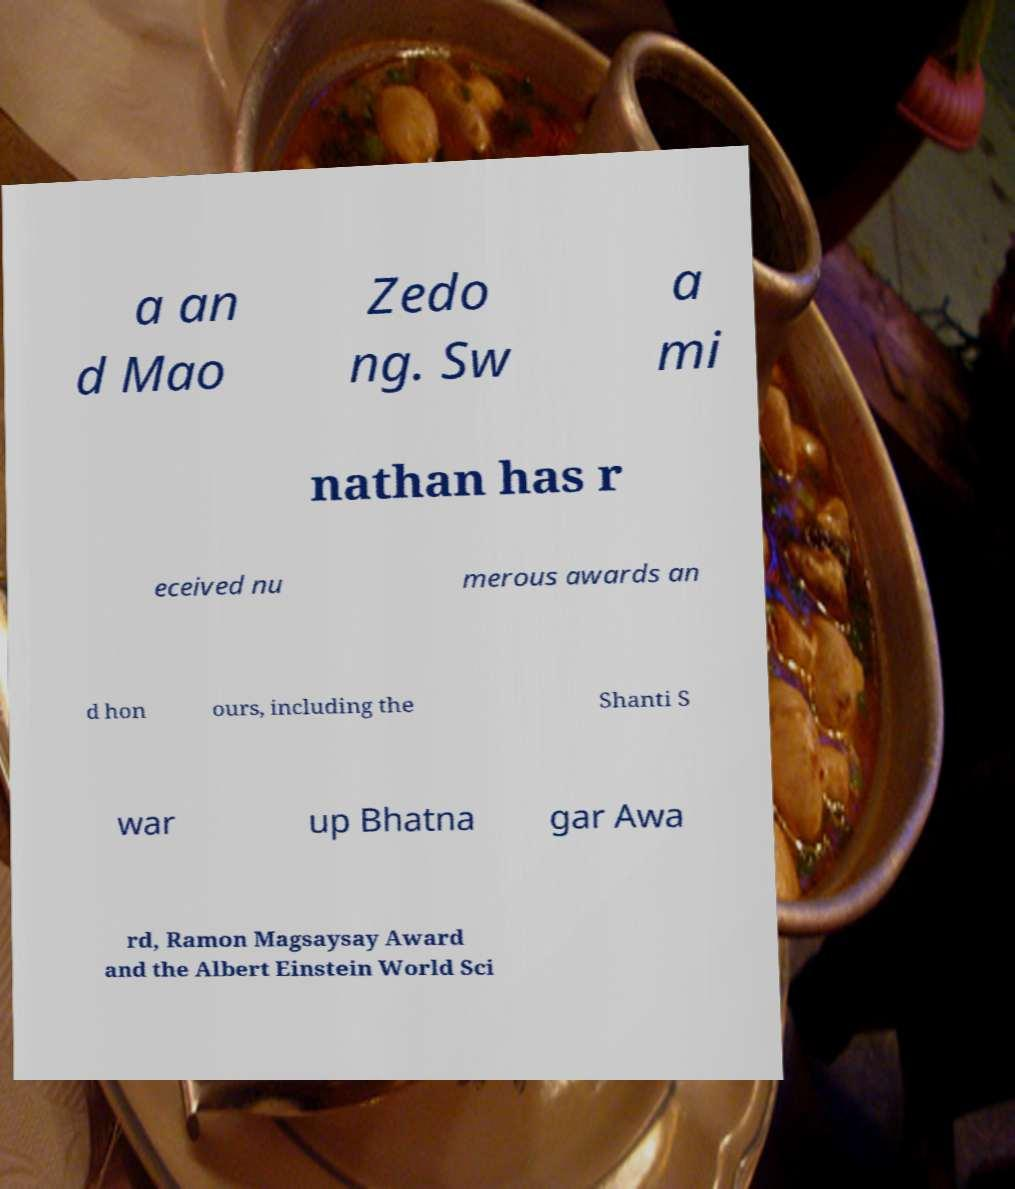I need the written content from this picture converted into text. Can you do that? a an d Mao Zedo ng. Sw a mi nathan has r eceived nu merous awards an d hon ours, including the Shanti S war up Bhatna gar Awa rd, Ramon Magsaysay Award and the Albert Einstein World Sci 